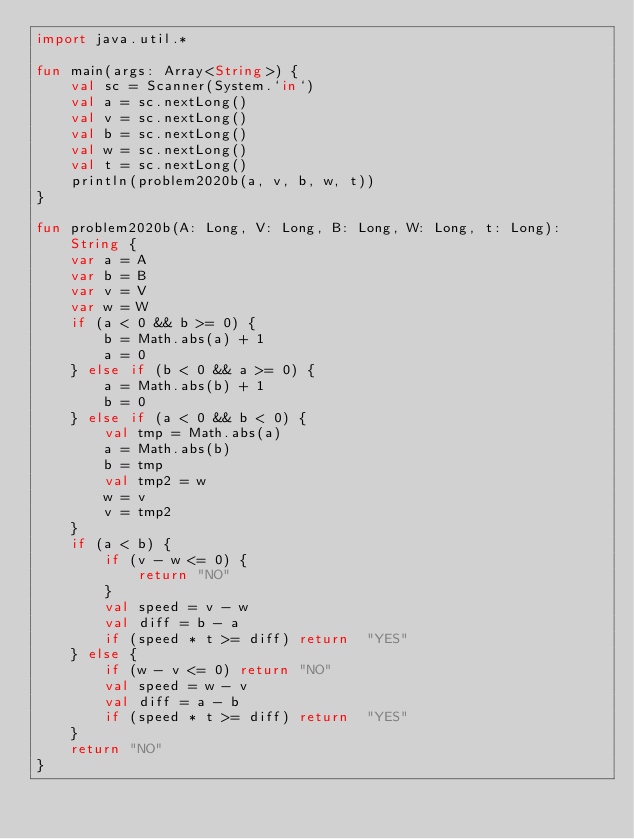<code> <loc_0><loc_0><loc_500><loc_500><_Kotlin_>import java.util.*

fun main(args: Array<String>) {
    val sc = Scanner(System.`in`)
    val a = sc.nextLong()
    val v = sc.nextLong()
    val b = sc.nextLong()
    val w = sc.nextLong()
    val t = sc.nextLong()
    println(problem2020b(a, v, b, w, t))
}

fun problem2020b(A: Long, V: Long, B: Long, W: Long, t: Long): String {
    var a = A
    var b = B
    var v = V
    var w = W
    if (a < 0 && b >= 0) {
        b = Math.abs(a) + 1
        a = 0
    } else if (b < 0 && a >= 0) {
        a = Math.abs(b) + 1
        b = 0
    } else if (a < 0 && b < 0) {
        val tmp = Math.abs(a)
        a = Math.abs(b)
        b = tmp
        val tmp2 = w
        w = v
        v = tmp2
    }
    if (a < b) {
        if (v - w <= 0) {
            return "NO"
        }
        val speed = v - w
        val diff = b - a
        if (speed * t >= diff) return  "YES"
    } else {
        if (w - v <= 0) return "NO"
        val speed = w - v
        val diff = a - b
        if (speed * t >= diff) return  "YES"
    }
    return "NO"
}</code> 